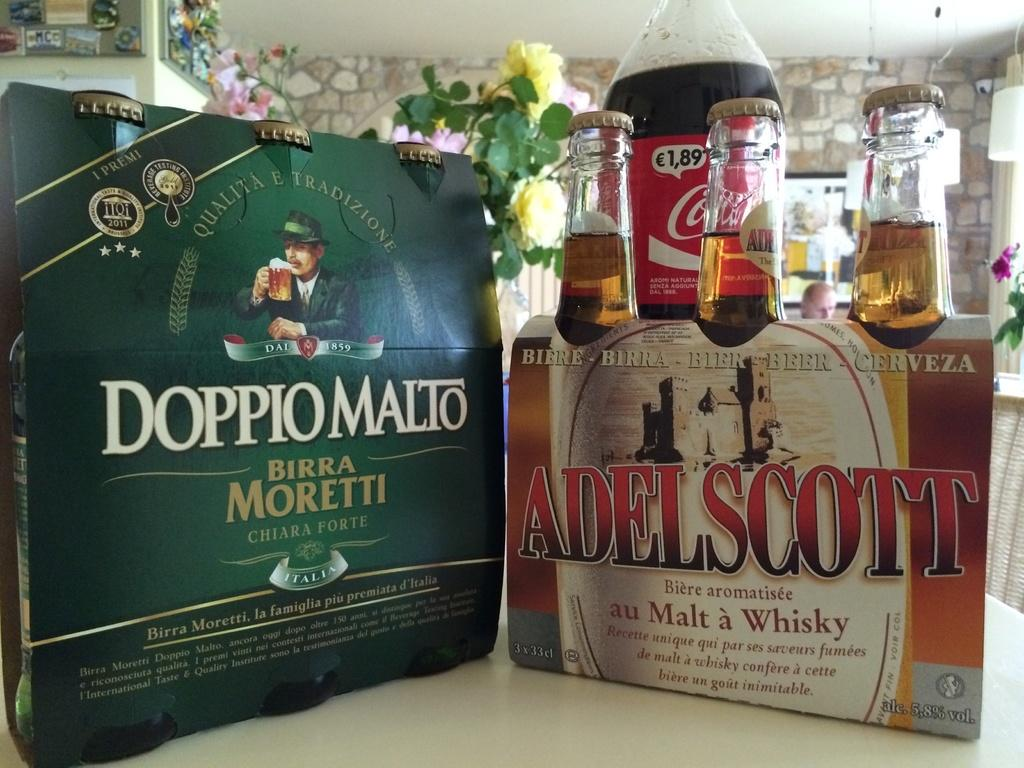<image>
Summarize the visual content of the image. Two packs of bottled liquor which one is Adelscott and the other Doppiomalto with a two liter of Coke Cola in the background. 